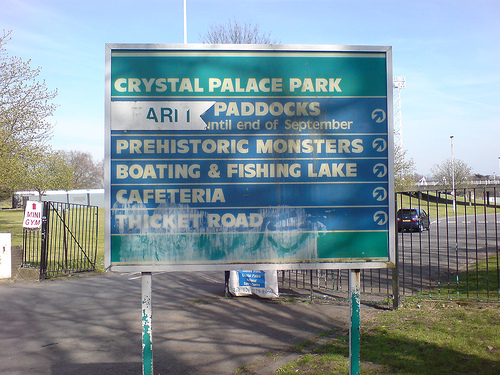<image>
Is there a gym behind the monsters? Yes. From this viewpoint, the gym is positioned behind the monsters, with the monsters partially or fully occluding the gym. 